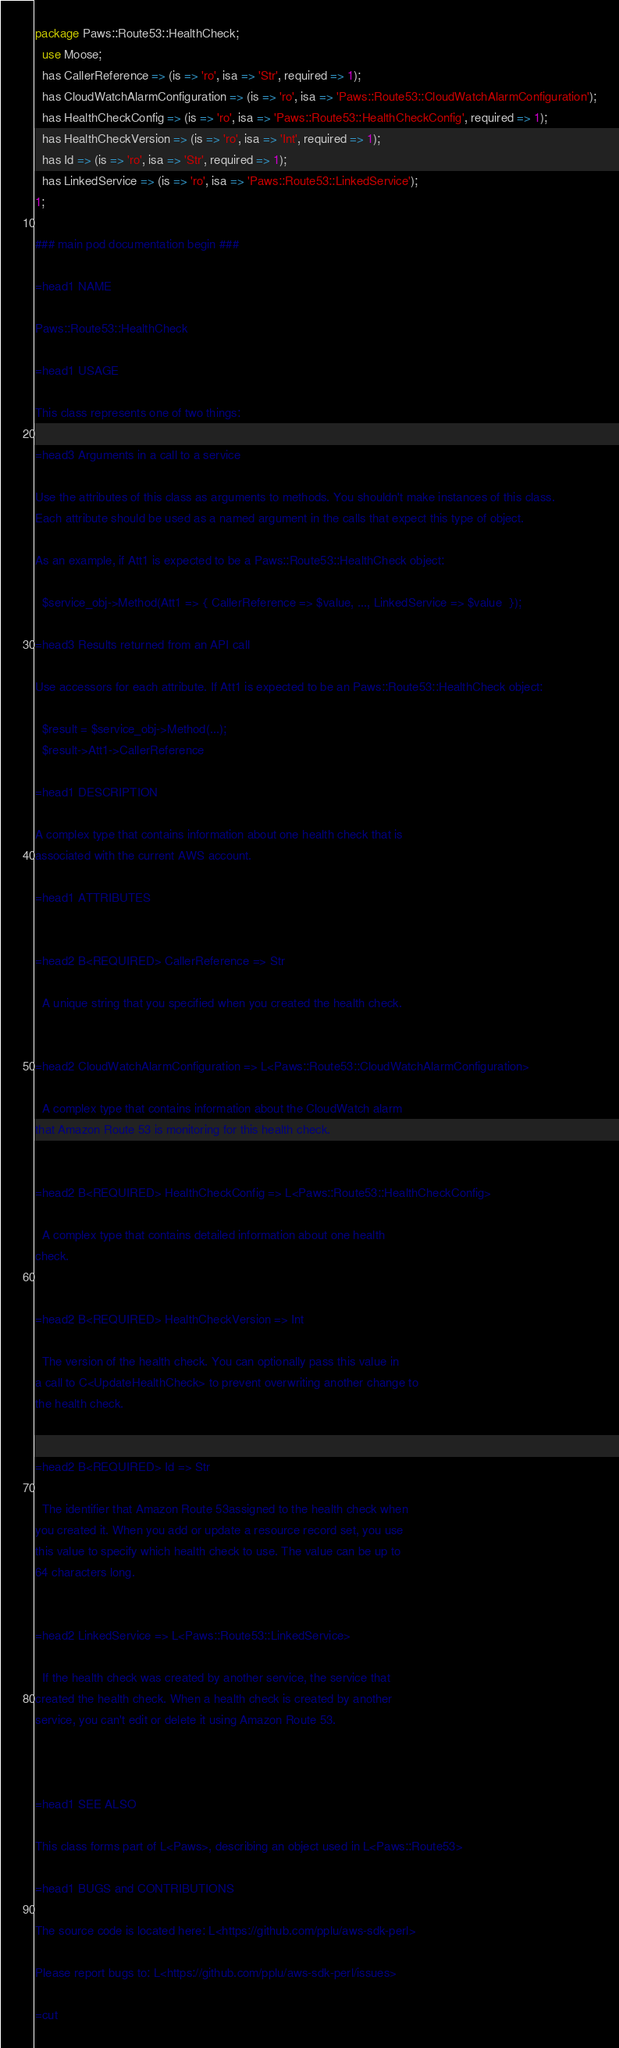<code> <loc_0><loc_0><loc_500><loc_500><_Perl_>package Paws::Route53::HealthCheck;
  use Moose;
  has CallerReference => (is => 'ro', isa => 'Str', required => 1);
  has CloudWatchAlarmConfiguration => (is => 'ro', isa => 'Paws::Route53::CloudWatchAlarmConfiguration');
  has HealthCheckConfig => (is => 'ro', isa => 'Paws::Route53::HealthCheckConfig', required => 1);
  has HealthCheckVersion => (is => 'ro', isa => 'Int', required => 1);
  has Id => (is => 'ro', isa => 'Str', required => 1);
  has LinkedService => (is => 'ro', isa => 'Paws::Route53::LinkedService');
1;

### main pod documentation begin ###

=head1 NAME

Paws::Route53::HealthCheck

=head1 USAGE

This class represents one of two things:

=head3 Arguments in a call to a service

Use the attributes of this class as arguments to methods. You shouldn't make instances of this class. 
Each attribute should be used as a named argument in the calls that expect this type of object.

As an example, if Att1 is expected to be a Paws::Route53::HealthCheck object:

  $service_obj->Method(Att1 => { CallerReference => $value, ..., LinkedService => $value  });

=head3 Results returned from an API call

Use accessors for each attribute. If Att1 is expected to be an Paws::Route53::HealthCheck object:

  $result = $service_obj->Method(...);
  $result->Att1->CallerReference

=head1 DESCRIPTION

A complex type that contains information about one health check that is
associated with the current AWS account.

=head1 ATTRIBUTES


=head2 B<REQUIRED> CallerReference => Str

  A unique string that you specified when you created the health check.


=head2 CloudWatchAlarmConfiguration => L<Paws::Route53::CloudWatchAlarmConfiguration>

  A complex type that contains information about the CloudWatch alarm
that Amazon Route 53 is monitoring for this health check.


=head2 B<REQUIRED> HealthCheckConfig => L<Paws::Route53::HealthCheckConfig>

  A complex type that contains detailed information about one health
check.


=head2 B<REQUIRED> HealthCheckVersion => Int

  The version of the health check. You can optionally pass this value in
a call to C<UpdateHealthCheck> to prevent overwriting another change to
the health check.


=head2 B<REQUIRED> Id => Str

  The identifier that Amazon Route 53assigned to the health check when
you created it. When you add or update a resource record set, you use
this value to specify which health check to use. The value can be up to
64 characters long.


=head2 LinkedService => L<Paws::Route53::LinkedService>

  If the health check was created by another service, the service that
created the health check. When a health check is created by another
service, you can't edit or delete it using Amazon Route 53.



=head1 SEE ALSO

This class forms part of L<Paws>, describing an object used in L<Paws::Route53>

=head1 BUGS and CONTRIBUTIONS

The source code is located here: L<https://github.com/pplu/aws-sdk-perl>

Please report bugs to: L<https://github.com/pplu/aws-sdk-perl/issues>

=cut

</code> 